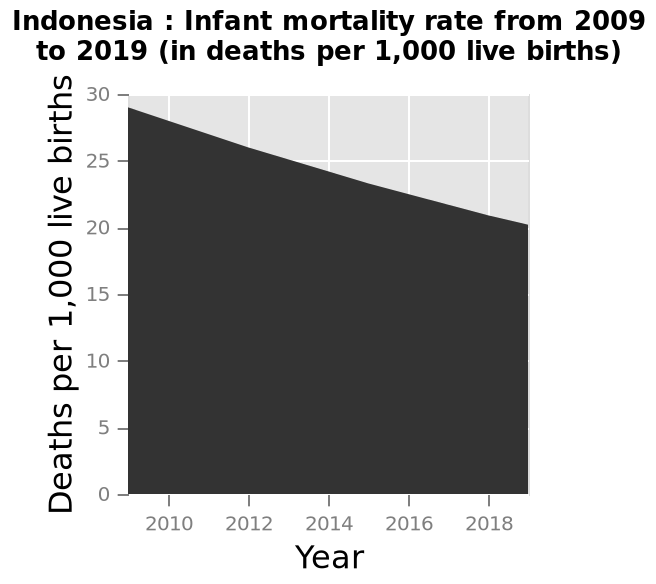<image>
How does the current number of deaths compare to the number ten years ago? The current number of deaths is almost 10% lower than it was ten years ago. 